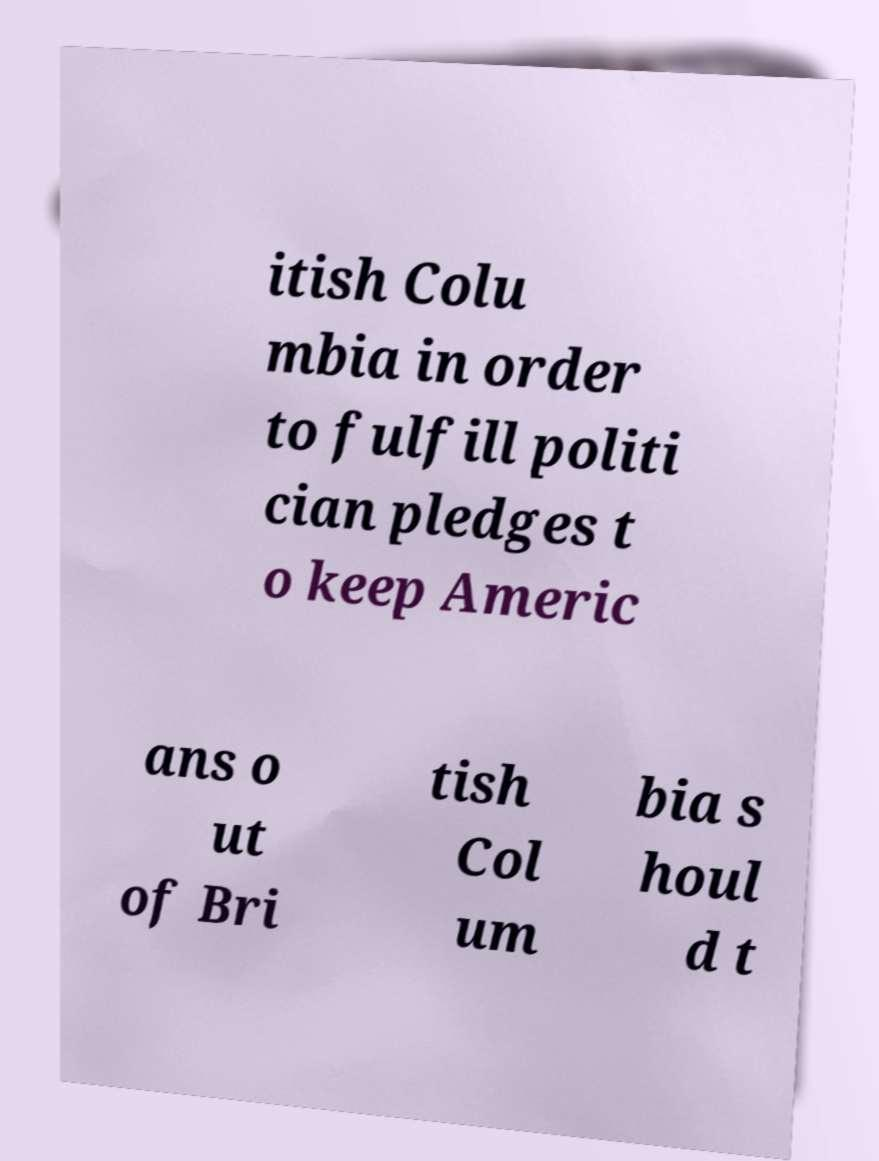Can you read and provide the text displayed in the image?This photo seems to have some interesting text. Can you extract and type it out for me? itish Colu mbia in order to fulfill politi cian pledges t o keep Americ ans o ut of Bri tish Col um bia s houl d t 